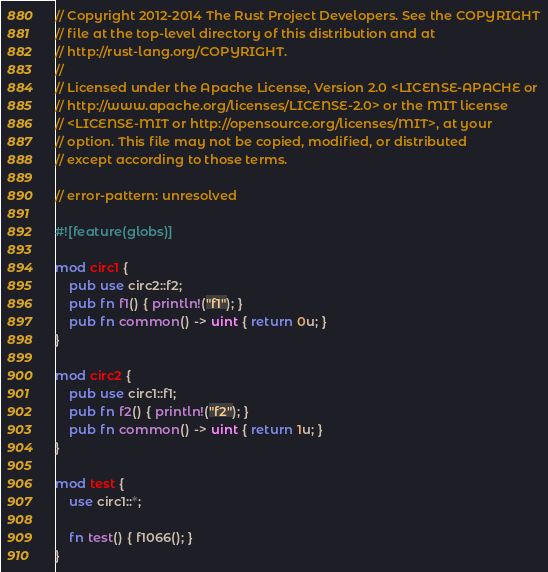<code> <loc_0><loc_0><loc_500><loc_500><_Rust_>// Copyright 2012-2014 The Rust Project Developers. See the COPYRIGHT
// file at the top-level directory of this distribution and at
// http://rust-lang.org/COPYRIGHT.
//
// Licensed under the Apache License, Version 2.0 <LICENSE-APACHE or
// http://www.apache.org/licenses/LICENSE-2.0> or the MIT license
// <LICENSE-MIT or http://opensource.org/licenses/MIT>, at your
// option. This file may not be copied, modified, or distributed
// except according to those terms.

// error-pattern: unresolved

#![feature(globs)]

mod circ1 {
    pub use circ2::f2;
    pub fn f1() { println!("f1"); }
    pub fn common() -> uint { return 0u; }
}

mod circ2 {
    pub use circ1::f1;
    pub fn f2() { println!("f2"); }
    pub fn common() -> uint { return 1u; }
}

mod test {
    use circ1::*;

    fn test() { f1066(); }
}
</code> 